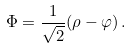<formula> <loc_0><loc_0><loc_500><loc_500>\Phi = { \frac { 1 } { \sqrt { 2 } } } ( \rho - \varphi ) \, .</formula> 